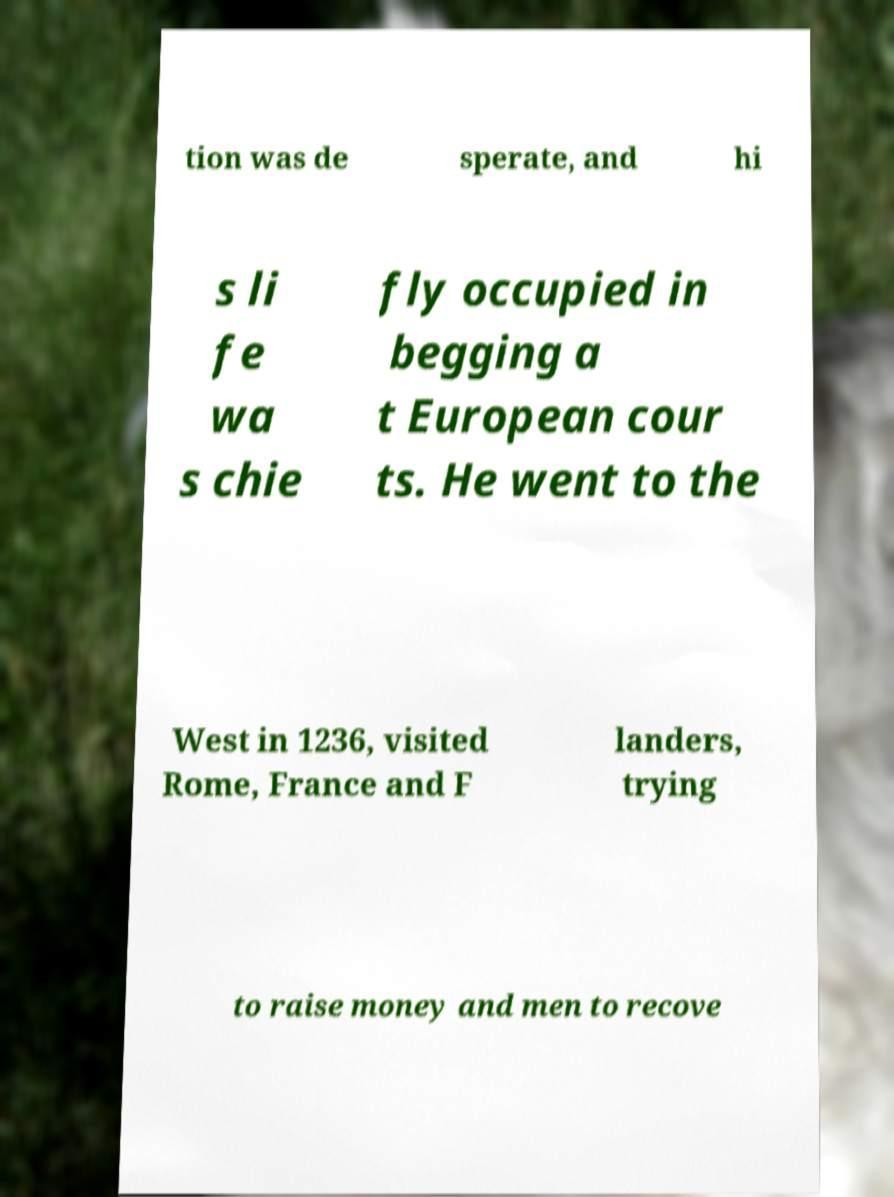Please read and relay the text visible in this image. What does it say? tion was de sperate, and hi s li fe wa s chie fly occupied in begging a t European cour ts. He went to the West in 1236, visited Rome, France and F landers, trying to raise money and men to recove 